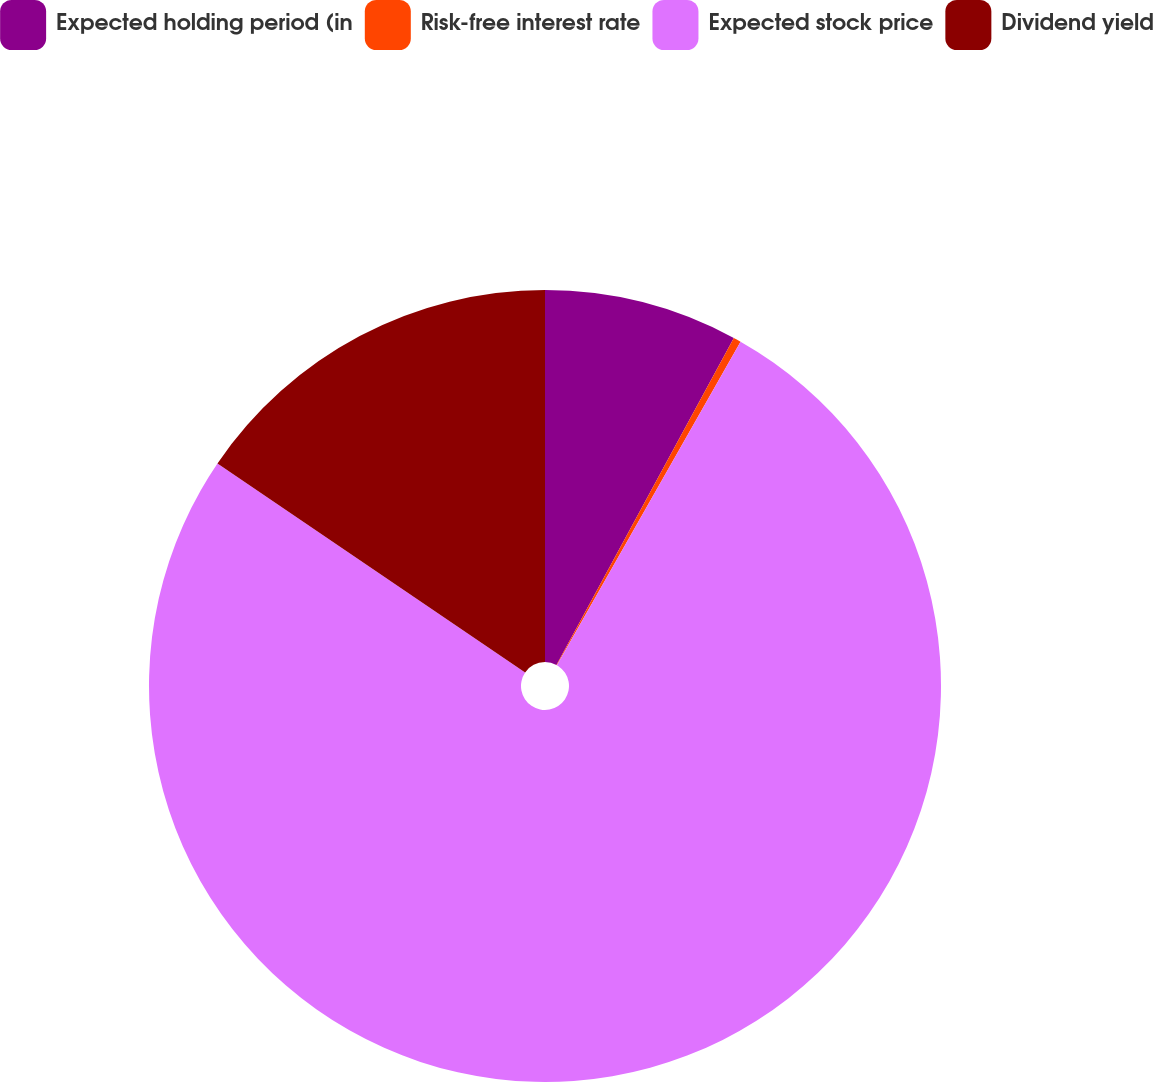<chart> <loc_0><loc_0><loc_500><loc_500><pie_chart><fcel>Expected holding period (in<fcel>Risk-free interest rate<fcel>Expected stock price<fcel>Dividend yield<nl><fcel>7.91%<fcel>0.31%<fcel>76.28%<fcel>15.5%<nl></chart> 